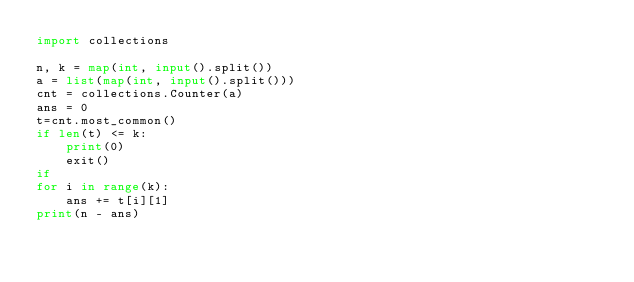<code> <loc_0><loc_0><loc_500><loc_500><_Python_>import collections

n, k = map(int, input().split())
a = list(map(int, input().split()))
cnt = collections.Counter(a)
ans = 0
t=cnt.most_common()
if len(t) <= k:
    print(0)
    exit()
if 
for i in range(k):
    ans += t[i][1]
print(n - ans)</code> 